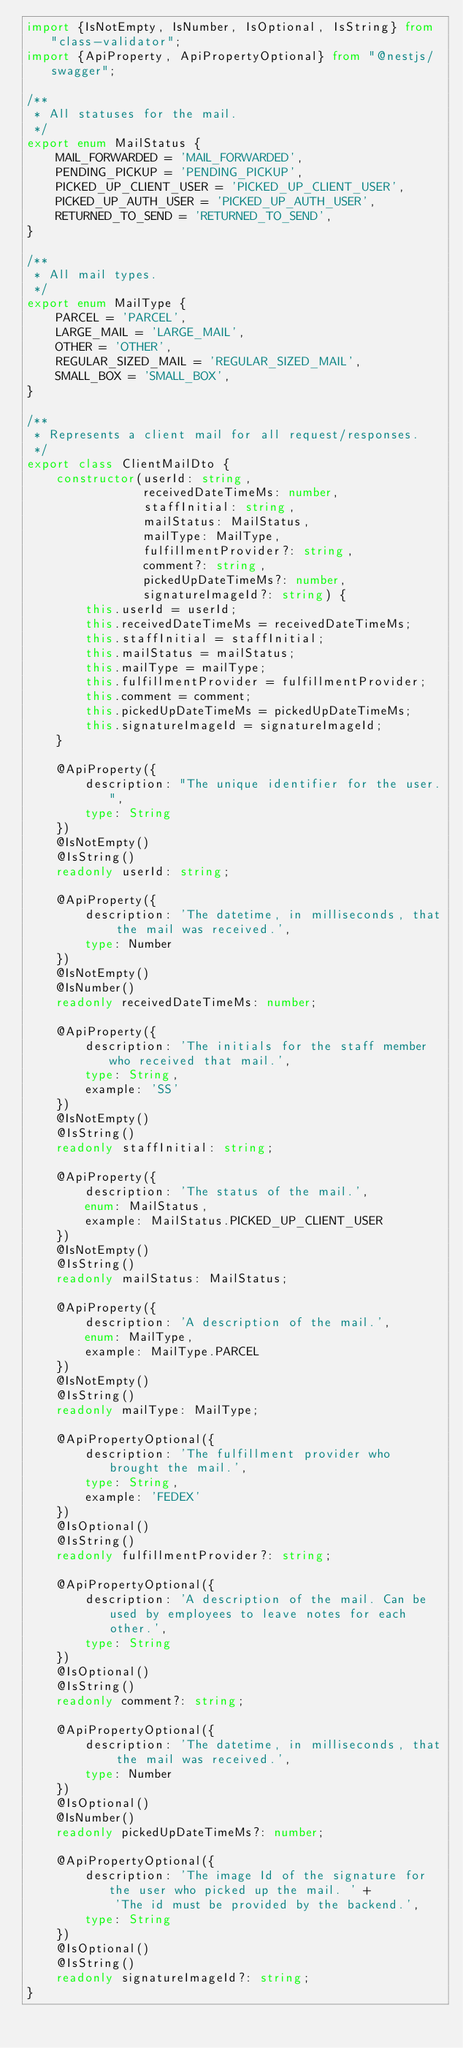<code> <loc_0><loc_0><loc_500><loc_500><_TypeScript_>import {IsNotEmpty, IsNumber, IsOptional, IsString} from "class-validator";
import {ApiProperty, ApiPropertyOptional} from "@nestjs/swagger";

/**
 * All statuses for the mail.
 */
export enum MailStatus {
    MAIL_FORWARDED = 'MAIL_FORWARDED',
    PENDING_PICKUP = 'PENDING_PICKUP',
    PICKED_UP_CLIENT_USER = 'PICKED_UP_CLIENT_USER',
    PICKED_UP_AUTH_USER = 'PICKED_UP_AUTH_USER',
    RETURNED_TO_SEND = 'RETURNED_TO_SEND',
}

/**
 * All mail types.
 */
export enum MailType {
    PARCEL = 'PARCEL',
    LARGE_MAIL = 'LARGE_MAIL',
    OTHER = 'OTHER',
    REGULAR_SIZED_MAIL = 'REGULAR_SIZED_MAIL',
    SMALL_BOX = 'SMALL_BOX',
}

/**
 * Represents a client mail for all request/responses.
 */
export class ClientMailDto {
    constructor(userId: string,
                receivedDateTimeMs: number,
                staffInitial: string,
                mailStatus: MailStatus,
                mailType: MailType,
                fulfillmentProvider?: string,
                comment?: string,
                pickedUpDateTimeMs?: number,
                signatureImageId?: string) {
        this.userId = userId;
        this.receivedDateTimeMs = receivedDateTimeMs;
        this.staffInitial = staffInitial;
        this.mailStatus = mailStatus;
        this.mailType = mailType;
        this.fulfillmentProvider = fulfillmentProvider;
        this.comment = comment;
        this.pickedUpDateTimeMs = pickedUpDateTimeMs;
        this.signatureImageId = signatureImageId;
    }

    @ApiProperty({
        description: "The unique identifier for the user.",
        type: String
    })
    @IsNotEmpty()
    @IsString()
    readonly userId: string;

    @ApiProperty({
        description: 'The datetime, in milliseconds, that the mail was received.',
        type: Number
    })
    @IsNotEmpty()
    @IsNumber()
    readonly receivedDateTimeMs: number;

    @ApiProperty({
        description: 'The initials for the staff member who received that mail.',
        type: String,
        example: 'SS'
    })
    @IsNotEmpty()
    @IsString()
    readonly staffInitial: string;

    @ApiProperty({
        description: 'The status of the mail.',
        enum: MailStatus,
        example: MailStatus.PICKED_UP_CLIENT_USER
    })
    @IsNotEmpty()
    @IsString()
    readonly mailStatus: MailStatus;

    @ApiProperty({
        description: 'A description of the mail.',
        enum: MailType,
        example: MailType.PARCEL
    })
    @IsNotEmpty()
    @IsString()
    readonly mailType: MailType;

    @ApiPropertyOptional({
        description: 'The fulfillment provider who brought the mail.',
        type: String,
        example: 'FEDEX'
    })
    @IsOptional()
    @IsString()
    readonly fulfillmentProvider?: string;

    @ApiPropertyOptional({
        description: 'A description of the mail. Can be used by employees to leave notes for each other.',
        type: String
    })
    @IsOptional()
    @IsString()
    readonly comment?: string;

    @ApiPropertyOptional({
        description: 'The datetime, in milliseconds, that the mail was received.',
        type: Number
    })
    @IsOptional()
    @IsNumber()
    readonly pickedUpDateTimeMs?: number;

    @ApiPropertyOptional({
        description: 'The image Id of the signature for the user who picked up the mail. ' +
            'The id must be provided by the backend.',
        type: String
    })
    @IsOptional()
    @IsString()
    readonly signatureImageId?: string;
}</code> 